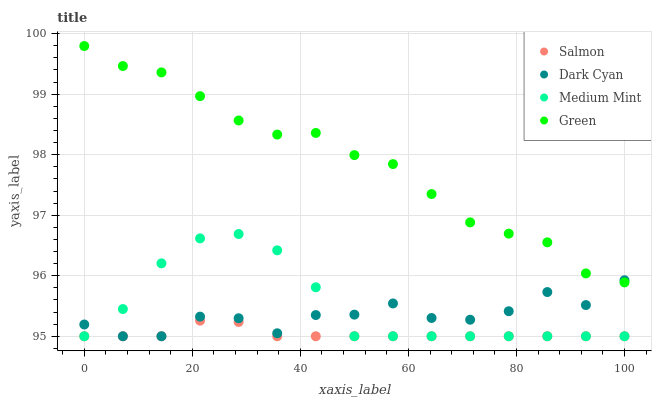Does Salmon have the minimum area under the curve?
Answer yes or no. Yes. Does Green have the maximum area under the curve?
Answer yes or no. Yes. Does Medium Mint have the minimum area under the curve?
Answer yes or no. No. Does Medium Mint have the maximum area under the curve?
Answer yes or no. No. Is Salmon the smoothest?
Answer yes or no. Yes. Is Dark Cyan the roughest?
Answer yes or no. Yes. Is Medium Mint the smoothest?
Answer yes or no. No. Is Medium Mint the roughest?
Answer yes or no. No. Does Dark Cyan have the lowest value?
Answer yes or no. Yes. Does Green have the lowest value?
Answer yes or no. No. Does Green have the highest value?
Answer yes or no. Yes. Does Medium Mint have the highest value?
Answer yes or no. No. Is Medium Mint less than Green?
Answer yes or no. Yes. Is Green greater than Salmon?
Answer yes or no. Yes. Does Salmon intersect Medium Mint?
Answer yes or no. Yes. Is Salmon less than Medium Mint?
Answer yes or no. No. Is Salmon greater than Medium Mint?
Answer yes or no. No. Does Medium Mint intersect Green?
Answer yes or no. No. 